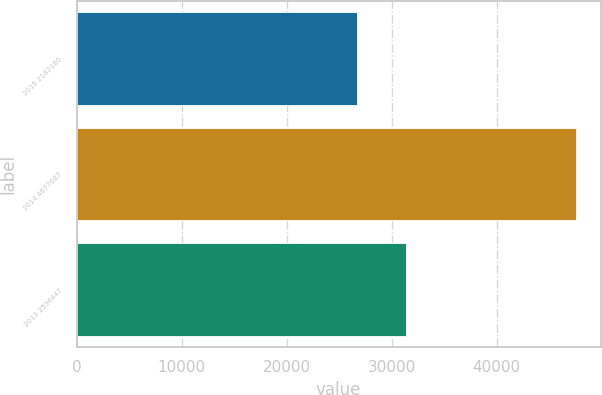Convert chart to OTSL. <chart><loc_0><loc_0><loc_500><loc_500><bar_chart><fcel>2015 2182180<fcel>2014 4677687<fcel>2013 2596447<nl><fcel>26751<fcel>47545.9<fcel>31349.5<nl></chart> 